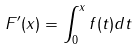Convert formula to latex. <formula><loc_0><loc_0><loc_500><loc_500>F ^ { \prime } ( x ) = \int _ { 0 } ^ { x } f ( t ) d t</formula> 